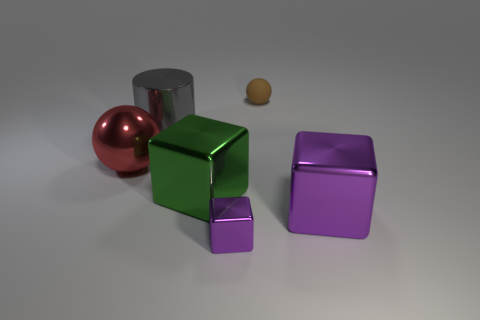There is a thing that is the same color as the small metallic block; what is its size?
Your answer should be very brief. Large. The object that is the same color as the small cube is what shape?
Offer a very short reply. Cube. Are there any other things that are the same material as the tiny ball?
Your answer should be compact. No. There is a purple metallic object that is in front of the large purple shiny block; does it have the same shape as the tiny object that is behind the big cylinder?
Give a very brief answer. No. How many small purple shiny blocks are there?
Make the answer very short. 1. What is the shape of the small thing that is the same material as the red sphere?
Offer a terse response. Cube. Is there any other thing of the same color as the tiny ball?
Provide a short and direct response. No. There is a big metallic cylinder; is its color the same as the ball left of the large metallic cylinder?
Provide a succinct answer. No. Are there fewer small brown balls that are in front of the tiny brown rubber sphere than big red objects?
Ensure brevity in your answer.  Yes. There is a cube that is on the right side of the rubber object; what material is it?
Your answer should be very brief. Metal. 